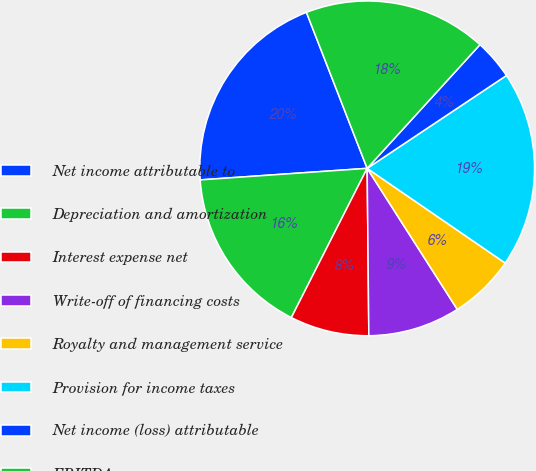Convert chart to OTSL. <chart><loc_0><loc_0><loc_500><loc_500><pie_chart><fcel>Net income attributable to<fcel>Depreciation and amortization<fcel>Interest expense net<fcel>Write-off of financing costs<fcel>Royalty and management service<fcel>Provision for income taxes<fcel>Net income (loss) attributable<fcel>EBITDA<nl><fcel>20.19%<fcel>16.42%<fcel>7.64%<fcel>8.89%<fcel>6.38%<fcel>18.93%<fcel>3.87%<fcel>17.68%<nl></chart> 